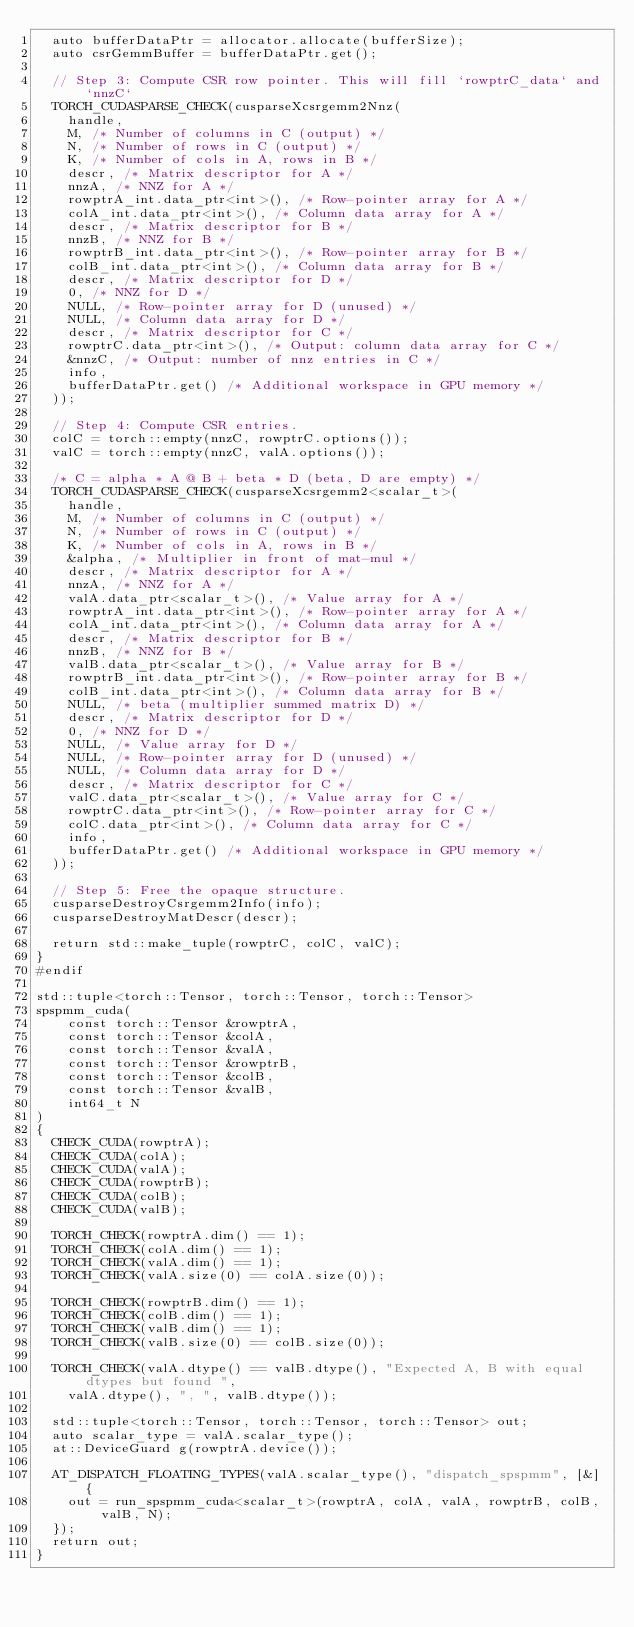Convert code to text. <code><loc_0><loc_0><loc_500><loc_500><_Cuda_>  auto bufferDataPtr = allocator.allocate(bufferSize);
  auto csrGemmBuffer = bufferDataPtr.get();

  // Step 3: Compute CSR row pointer. This will fill `rowptrC_data` and `nnzC`
  TORCH_CUDASPARSE_CHECK(cusparseXcsrgemm2Nnz(
    handle,
    M, /* Number of columns in C (output) */
    N, /* Number of rows in C (output) */
    K, /* Number of cols in A, rows in B */
    descr, /* Matrix descriptor for A */
    nnzA, /* NNZ for A */
    rowptrA_int.data_ptr<int>(), /* Row-pointer array for A */
    colA_int.data_ptr<int>(), /* Column data array for A */
    descr, /* Matrix descriptor for B */
    nnzB, /* NNZ for B */
    rowptrB_int.data_ptr<int>(), /* Row-pointer array for B */
    colB_int.data_ptr<int>(), /* Column data array for B */
    descr, /* Matrix descriptor for D */
    0, /* NNZ for D */
    NULL, /* Row-pointer array for D (unused) */
    NULL, /* Column data array for D */
    descr, /* Matrix descriptor for C */
    rowptrC.data_ptr<int>(), /* Output: column data array for C */
    &nnzC, /* Output: number of nnz entries in C */
    info,
    bufferDataPtr.get() /* Additional workspace in GPU memory */
  ));

  // Step 4: Compute CSR entries.
  colC = torch::empty(nnzC, rowptrC.options());
  valC = torch::empty(nnzC, valA.options());

  /* C = alpha * A @ B + beta * D (beta, D are empty) */
  TORCH_CUDASPARSE_CHECK(cusparseXcsrgemm2<scalar_t>(
    handle,
    M, /* Number of columns in C (output) */
    N, /* Number of rows in C (output) */
    K, /* Number of cols in A, rows in B */
    &alpha, /* Multiplier in front of mat-mul */
    descr, /* Matrix descriptor for A */
    nnzA, /* NNZ for A */
    valA.data_ptr<scalar_t>(), /* Value array for A */
    rowptrA_int.data_ptr<int>(), /* Row-pointer array for A */
    colA_int.data_ptr<int>(), /* Column data array for A */
    descr, /* Matrix descriptor for B */
    nnzB, /* NNZ for B */
    valB.data_ptr<scalar_t>(), /* Value array for B */
    rowptrB_int.data_ptr<int>(), /* Row-pointer array for B */
    colB_int.data_ptr<int>(), /* Column data array for B */
    NULL, /* beta (multiplier summed matrix D) */
    descr, /* Matrix descriptor for D */
    0, /* NNZ for D */
    NULL, /* Value array for D */
    NULL, /* Row-pointer array for D (unused) */
    NULL, /* Column data array for D */
    descr, /* Matrix descriptor for C */
    valC.data_ptr<scalar_t>(), /* Value array for C */
    rowptrC.data_ptr<int>(), /* Row-pointer array for C */
    colC.data_ptr<int>(), /* Column data array for C */
    info,
    bufferDataPtr.get() /* Additional workspace in GPU memory */
  ));

  // Step 5: Free the opaque structure.
  cusparseDestroyCsrgemm2Info(info);
  cusparseDestroyMatDescr(descr);

  return std::make_tuple(rowptrC, colC, valC);
}
#endif

std::tuple<torch::Tensor, torch::Tensor, torch::Tensor>
spspmm_cuda(
    const torch::Tensor &rowptrA,
    const torch::Tensor &colA,
    const torch::Tensor &valA,
    const torch::Tensor &rowptrB,
    const torch::Tensor &colB,
    const torch::Tensor &valB,
    int64_t N
)
{
  CHECK_CUDA(rowptrA);
  CHECK_CUDA(colA);
  CHECK_CUDA(valA);
  CHECK_CUDA(rowptrB);
  CHECK_CUDA(colB);
  CHECK_CUDA(valB);

  TORCH_CHECK(rowptrA.dim() == 1);
  TORCH_CHECK(colA.dim() == 1);
  TORCH_CHECK(valA.dim() == 1);
  TORCH_CHECK(valA.size(0) == colA.size(0));

  TORCH_CHECK(rowptrB.dim() == 1);
  TORCH_CHECK(colB.dim() == 1);
  TORCH_CHECK(valB.dim() == 1);
  TORCH_CHECK(valB.size(0) == colB.size(0));

  TORCH_CHECK(valA.dtype() == valB.dtype(), "Expected A, B with equal dtypes but found ",
    valA.dtype(), ", ", valB.dtype());

  std::tuple<torch::Tensor, torch::Tensor, torch::Tensor> out;
  auto scalar_type = valA.scalar_type();
  at::DeviceGuard g(rowptrA.device());

  AT_DISPATCH_FLOATING_TYPES(valA.scalar_type(), "dispatch_spspmm", [&] {
    out = run_spspmm_cuda<scalar_t>(rowptrA, colA, valA, rowptrB, colB, valB, N);
  });
  return out;
}
</code> 